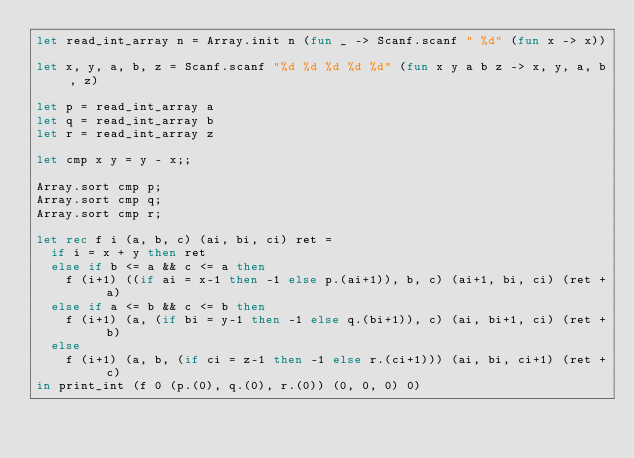Convert code to text. <code><loc_0><loc_0><loc_500><loc_500><_OCaml_>let read_int_array n = Array.init n (fun _ -> Scanf.scanf " %d" (fun x -> x))

let x, y, a, b, z = Scanf.scanf "%d %d %d %d %d" (fun x y a b z -> x, y, a, b, z)

let p = read_int_array a
let q = read_int_array b
let r = read_int_array z

let cmp x y = y - x;;

Array.sort cmp p;
Array.sort cmp q;
Array.sort cmp r;

let rec f i (a, b, c) (ai, bi, ci) ret =
  if i = x + y then ret
  else if b <= a && c <= a then
    f (i+1) ((if ai = x-1 then -1 else p.(ai+1)), b, c) (ai+1, bi, ci) (ret + a)
  else if a <= b && c <= b then
    f (i+1) (a, (if bi = y-1 then -1 else q.(bi+1)), c) (ai, bi+1, ci) (ret + b)
  else
    f (i+1) (a, b, (if ci = z-1 then -1 else r.(ci+1))) (ai, bi, ci+1) (ret + c)
in print_int (f 0 (p.(0), q.(0), r.(0)) (0, 0, 0) 0)
</code> 